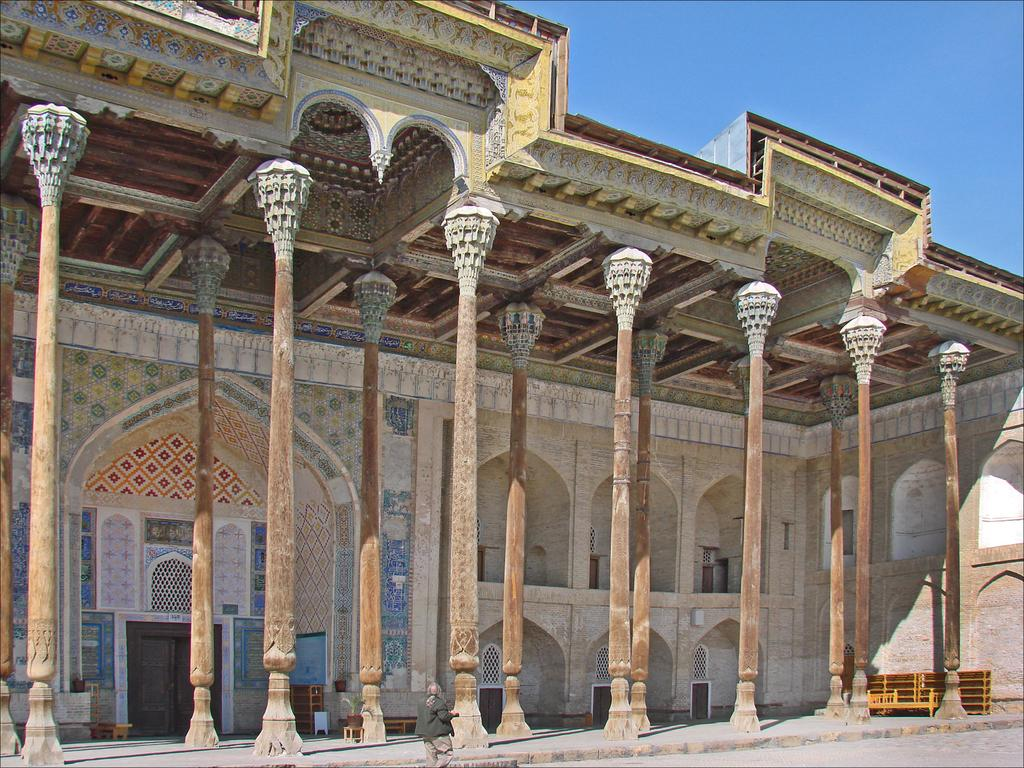What is the main subject of the image? There is a person walking in the image. What can be seen in the background of the image? There are pillars of a building beside the person. What type of object made of wood is present in the image? There is a wooden object in the image. What type of band is playing in the background of the image? There is no band present in the image. What is the frame of the image made of? The frame of the image is not visible in the image itself, as it is a two-dimensional representation. Can you see the person's thumb in the image? The image does not provide enough detail to determine if the person's thumb is visible or not. 